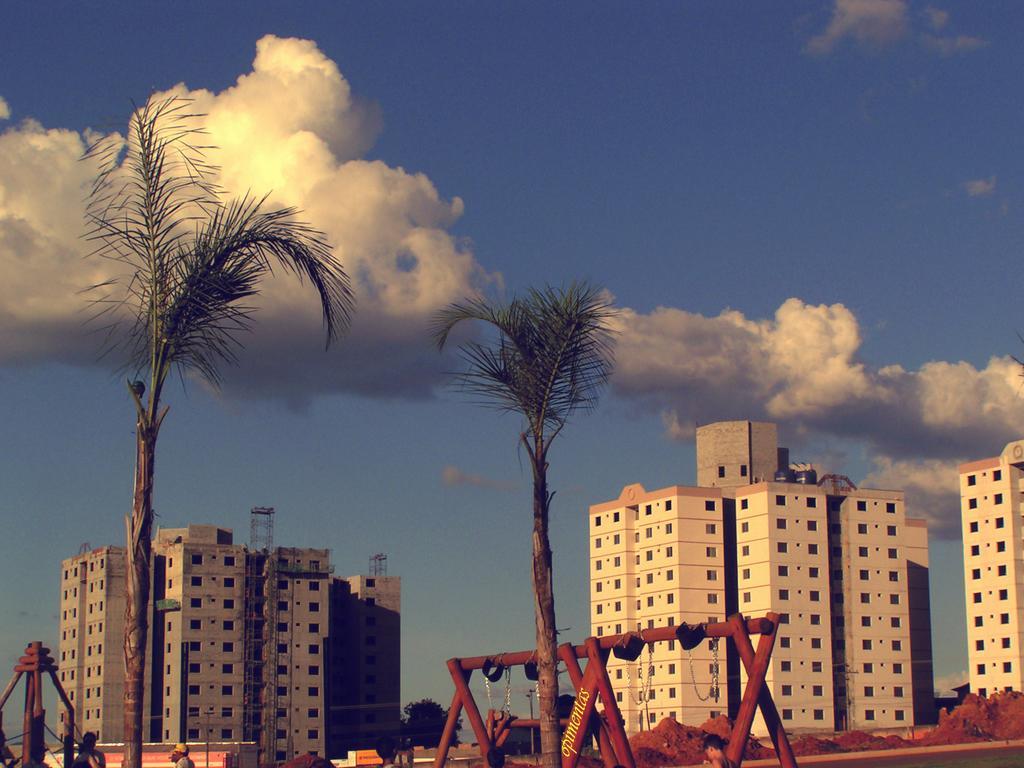Could you give a brief overview of what you see in this image? In this image there are buildings and trees. 